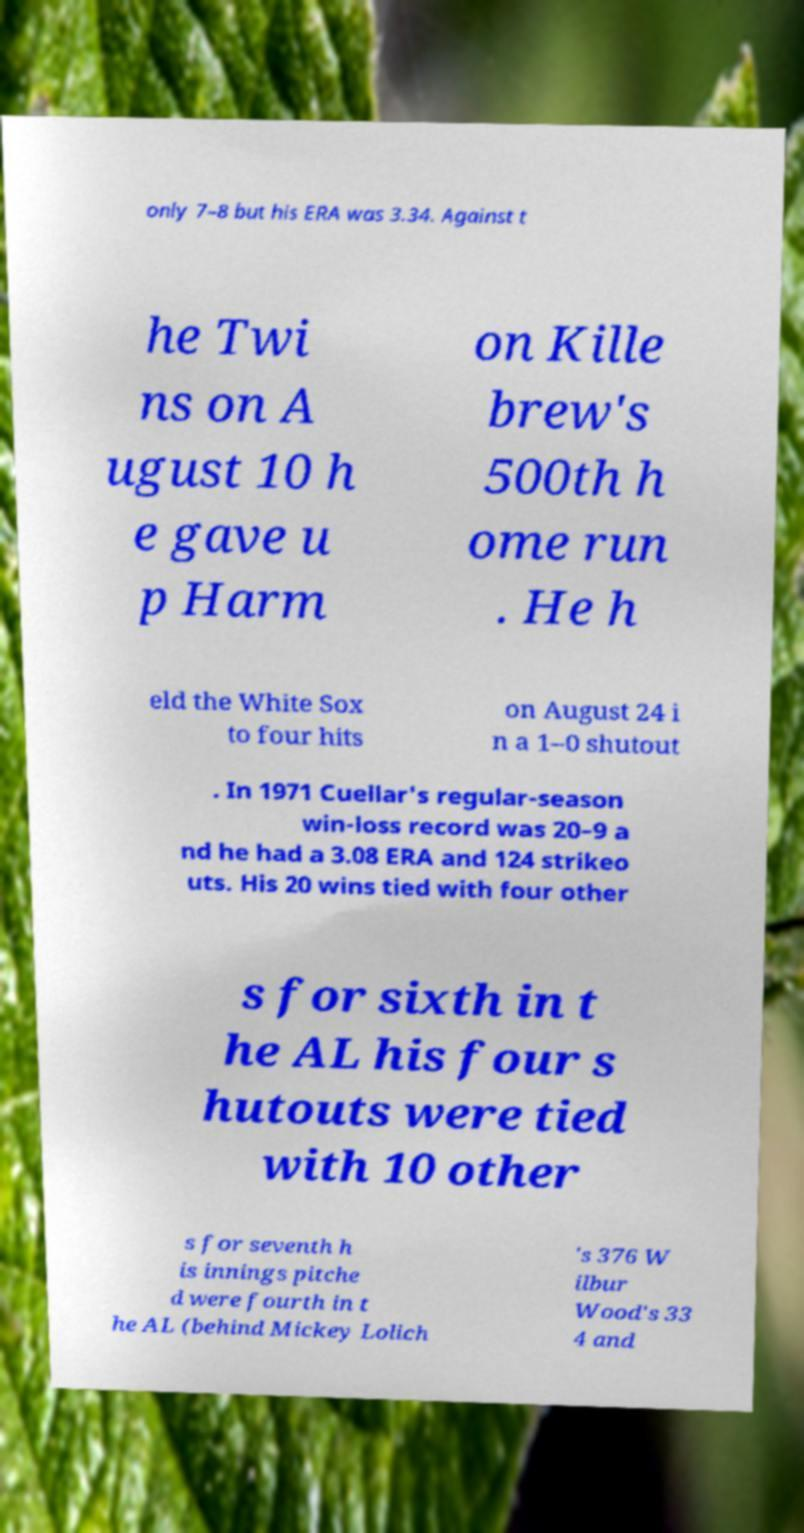I need the written content from this picture converted into text. Can you do that? only 7–8 but his ERA was 3.34. Against t he Twi ns on A ugust 10 h e gave u p Harm on Kille brew's 500th h ome run . He h eld the White Sox to four hits on August 24 i n a 1–0 shutout . In 1971 Cuellar's regular-season win-loss record was 20–9 a nd he had a 3.08 ERA and 124 strikeo uts. His 20 wins tied with four other s for sixth in t he AL his four s hutouts were tied with 10 other s for seventh h is innings pitche d were fourth in t he AL (behind Mickey Lolich 's 376 W ilbur Wood's 33 4 and 